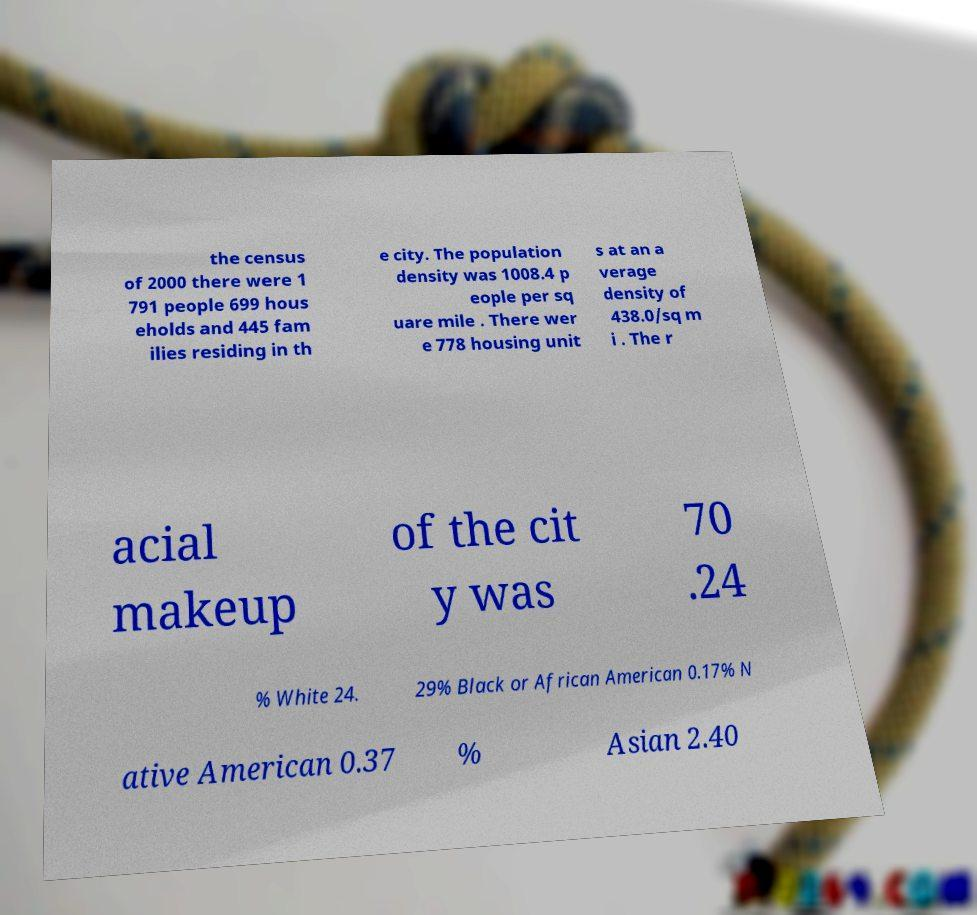Can you read and provide the text displayed in the image?This photo seems to have some interesting text. Can you extract and type it out for me? the census of 2000 there were 1 791 people 699 hous eholds and 445 fam ilies residing in th e city. The population density was 1008.4 p eople per sq uare mile . There wer e 778 housing unit s at an a verage density of 438.0/sq m i . The r acial makeup of the cit y was 70 .24 % White 24. 29% Black or African American 0.17% N ative American 0.37 % Asian 2.40 